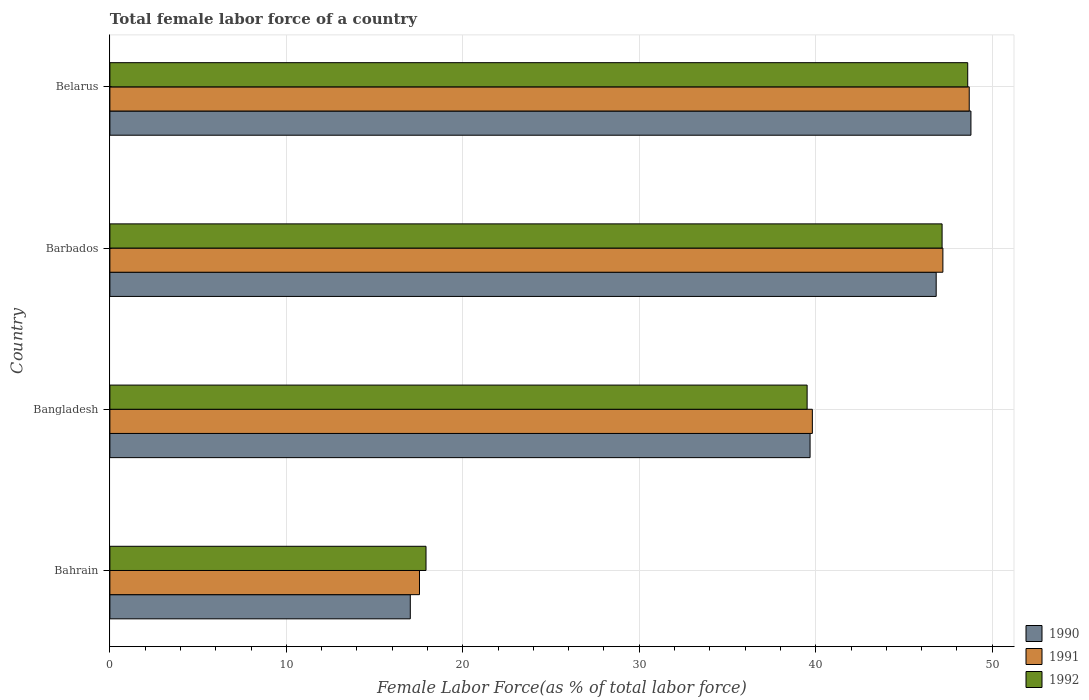How many groups of bars are there?
Your answer should be compact. 4. Are the number of bars on each tick of the Y-axis equal?
Ensure brevity in your answer.  Yes. What is the label of the 4th group of bars from the top?
Keep it short and to the point. Bahrain. What is the percentage of female labor force in 1992 in Bahrain?
Your answer should be very brief. 17.92. Across all countries, what is the maximum percentage of female labor force in 1991?
Provide a short and direct response. 48.7. Across all countries, what is the minimum percentage of female labor force in 1992?
Offer a terse response. 17.92. In which country was the percentage of female labor force in 1992 maximum?
Provide a succinct answer. Belarus. In which country was the percentage of female labor force in 1990 minimum?
Your response must be concise. Bahrain. What is the total percentage of female labor force in 1992 in the graph?
Offer a terse response. 153.21. What is the difference between the percentage of female labor force in 1991 in Bangladesh and that in Belarus?
Provide a short and direct response. -8.89. What is the difference between the percentage of female labor force in 1990 in Barbados and the percentage of female labor force in 1991 in Bahrain?
Keep it short and to the point. 29.28. What is the average percentage of female labor force in 1990 per country?
Offer a very short reply. 38.08. What is the difference between the percentage of female labor force in 1992 and percentage of female labor force in 1990 in Bangladesh?
Offer a very short reply. -0.17. What is the ratio of the percentage of female labor force in 1992 in Bahrain to that in Barbados?
Make the answer very short. 0.38. Is the percentage of female labor force in 1990 in Barbados less than that in Belarus?
Provide a succinct answer. Yes. What is the difference between the highest and the second highest percentage of female labor force in 1992?
Your response must be concise. 1.45. What is the difference between the highest and the lowest percentage of female labor force in 1992?
Provide a succinct answer. 30.7. In how many countries, is the percentage of female labor force in 1992 greater than the average percentage of female labor force in 1992 taken over all countries?
Keep it short and to the point. 3. Is the sum of the percentage of female labor force in 1990 in Barbados and Belarus greater than the maximum percentage of female labor force in 1991 across all countries?
Your response must be concise. Yes. What does the 1st bar from the bottom in Barbados represents?
Offer a very short reply. 1990. Is it the case that in every country, the sum of the percentage of female labor force in 1992 and percentage of female labor force in 1990 is greater than the percentage of female labor force in 1991?
Ensure brevity in your answer.  Yes. How many countries are there in the graph?
Provide a short and direct response. 4. What is the difference between two consecutive major ticks on the X-axis?
Your answer should be very brief. 10. Does the graph contain grids?
Your answer should be very brief. Yes. How many legend labels are there?
Provide a succinct answer. 3. What is the title of the graph?
Keep it short and to the point. Total female labor force of a country. Does "1996" appear as one of the legend labels in the graph?
Your answer should be very brief. No. What is the label or title of the X-axis?
Your answer should be compact. Female Labor Force(as % of total labor force). What is the label or title of the Y-axis?
Your answer should be compact. Country. What is the Female Labor Force(as % of total labor force) in 1990 in Bahrain?
Provide a short and direct response. 17.02. What is the Female Labor Force(as % of total labor force) of 1991 in Bahrain?
Your answer should be very brief. 17.55. What is the Female Labor Force(as % of total labor force) in 1992 in Bahrain?
Your answer should be compact. 17.92. What is the Female Labor Force(as % of total labor force) in 1990 in Bangladesh?
Provide a succinct answer. 39.68. What is the Female Labor Force(as % of total labor force) of 1991 in Bangladesh?
Your answer should be compact. 39.81. What is the Female Labor Force(as % of total labor force) of 1992 in Bangladesh?
Your answer should be very brief. 39.51. What is the Female Labor Force(as % of total labor force) in 1990 in Barbados?
Offer a terse response. 46.83. What is the Female Labor Force(as % of total labor force) of 1991 in Barbados?
Your answer should be compact. 47.21. What is the Female Labor Force(as % of total labor force) in 1992 in Barbados?
Offer a terse response. 47.16. What is the Female Labor Force(as % of total labor force) of 1990 in Belarus?
Offer a very short reply. 48.8. What is the Female Labor Force(as % of total labor force) in 1991 in Belarus?
Offer a very short reply. 48.7. What is the Female Labor Force(as % of total labor force) of 1992 in Belarus?
Your response must be concise. 48.61. Across all countries, what is the maximum Female Labor Force(as % of total labor force) in 1990?
Offer a terse response. 48.8. Across all countries, what is the maximum Female Labor Force(as % of total labor force) of 1991?
Your answer should be compact. 48.7. Across all countries, what is the maximum Female Labor Force(as % of total labor force) of 1992?
Ensure brevity in your answer.  48.61. Across all countries, what is the minimum Female Labor Force(as % of total labor force) of 1990?
Your response must be concise. 17.02. Across all countries, what is the minimum Female Labor Force(as % of total labor force) of 1991?
Offer a very short reply. 17.55. Across all countries, what is the minimum Female Labor Force(as % of total labor force) of 1992?
Your response must be concise. 17.92. What is the total Female Labor Force(as % of total labor force) of 1990 in the graph?
Offer a very short reply. 152.33. What is the total Female Labor Force(as % of total labor force) in 1991 in the graph?
Offer a very short reply. 153.26. What is the total Female Labor Force(as % of total labor force) in 1992 in the graph?
Give a very brief answer. 153.21. What is the difference between the Female Labor Force(as % of total labor force) of 1990 in Bahrain and that in Bangladesh?
Provide a succinct answer. -22.66. What is the difference between the Female Labor Force(as % of total labor force) in 1991 in Bahrain and that in Bangladesh?
Make the answer very short. -22.26. What is the difference between the Female Labor Force(as % of total labor force) of 1992 in Bahrain and that in Bangladesh?
Keep it short and to the point. -21.6. What is the difference between the Female Labor Force(as % of total labor force) in 1990 in Bahrain and that in Barbados?
Offer a very short reply. -29.8. What is the difference between the Female Labor Force(as % of total labor force) in 1991 in Bahrain and that in Barbados?
Your answer should be compact. -29.66. What is the difference between the Female Labor Force(as % of total labor force) in 1992 in Bahrain and that in Barbados?
Keep it short and to the point. -29.25. What is the difference between the Female Labor Force(as % of total labor force) of 1990 in Bahrain and that in Belarus?
Your response must be concise. -31.77. What is the difference between the Female Labor Force(as % of total labor force) of 1991 in Bahrain and that in Belarus?
Your response must be concise. -31.16. What is the difference between the Female Labor Force(as % of total labor force) of 1992 in Bahrain and that in Belarus?
Offer a terse response. -30.7. What is the difference between the Female Labor Force(as % of total labor force) in 1990 in Bangladesh and that in Barbados?
Keep it short and to the point. -7.15. What is the difference between the Female Labor Force(as % of total labor force) of 1991 in Bangladesh and that in Barbados?
Your answer should be compact. -7.4. What is the difference between the Female Labor Force(as % of total labor force) of 1992 in Bangladesh and that in Barbados?
Your answer should be very brief. -7.65. What is the difference between the Female Labor Force(as % of total labor force) of 1990 in Bangladesh and that in Belarus?
Ensure brevity in your answer.  -9.12. What is the difference between the Female Labor Force(as % of total labor force) of 1991 in Bangladesh and that in Belarus?
Provide a succinct answer. -8.89. What is the difference between the Female Labor Force(as % of total labor force) in 1992 in Bangladesh and that in Belarus?
Make the answer very short. -9.1. What is the difference between the Female Labor Force(as % of total labor force) of 1990 in Barbados and that in Belarus?
Your response must be concise. -1.97. What is the difference between the Female Labor Force(as % of total labor force) in 1991 in Barbados and that in Belarus?
Provide a succinct answer. -1.49. What is the difference between the Female Labor Force(as % of total labor force) in 1992 in Barbados and that in Belarus?
Your response must be concise. -1.45. What is the difference between the Female Labor Force(as % of total labor force) of 1990 in Bahrain and the Female Labor Force(as % of total labor force) of 1991 in Bangladesh?
Keep it short and to the point. -22.79. What is the difference between the Female Labor Force(as % of total labor force) of 1990 in Bahrain and the Female Labor Force(as % of total labor force) of 1992 in Bangladesh?
Offer a terse response. -22.49. What is the difference between the Female Labor Force(as % of total labor force) in 1991 in Bahrain and the Female Labor Force(as % of total labor force) in 1992 in Bangladesh?
Offer a terse response. -21.97. What is the difference between the Female Labor Force(as % of total labor force) in 1990 in Bahrain and the Female Labor Force(as % of total labor force) in 1991 in Barbados?
Provide a succinct answer. -30.18. What is the difference between the Female Labor Force(as % of total labor force) of 1990 in Bahrain and the Female Labor Force(as % of total labor force) of 1992 in Barbados?
Your response must be concise. -30.14. What is the difference between the Female Labor Force(as % of total labor force) in 1991 in Bahrain and the Female Labor Force(as % of total labor force) in 1992 in Barbados?
Make the answer very short. -29.62. What is the difference between the Female Labor Force(as % of total labor force) in 1990 in Bahrain and the Female Labor Force(as % of total labor force) in 1991 in Belarus?
Provide a succinct answer. -31.68. What is the difference between the Female Labor Force(as % of total labor force) of 1990 in Bahrain and the Female Labor Force(as % of total labor force) of 1992 in Belarus?
Offer a very short reply. -31.59. What is the difference between the Female Labor Force(as % of total labor force) of 1991 in Bahrain and the Female Labor Force(as % of total labor force) of 1992 in Belarus?
Provide a short and direct response. -31.07. What is the difference between the Female Labor Force(as % of total labor force) in 1990 in Bangladesh and the Female Labor Force(as % of total labor force) in 1991 in Barbados?
Keep it short and to the point. -7.53. What is the difference between the Female Labor Force(as % of total labor force) of 1990 in Bangladesh and the Female Labor Force(as % of total labor force) of 1992 in Barbados?
Ensure brevity in your answer.  -7.48. What is the difference between the Female Labor Force(as % of total labor force) in 1991 in Bangladesh and the Female Labor Force(as % of total labor force) in 1992 in Barbados?
Make the answer very short. -7.35. What is the difference between the Female Labor Force(as % of total labor force) of 1990 in Bangladesh and the Female Labor Force(as % of total labor force) of 1991 in Belarus?
Your answer should be compact. -9.02. What is the difference between the Female Labor Force(as % of total labor force) in 1990 in Bangladesh and the Female Labor Force(as % of total labor force) in 1992 in Belarus?
Keep it short and to the point. -8.93. What is the difference between the Female Labor Force(as % of total labor force) of 1991 in Bangladesh and the Female Labor Force(as % of total labor force) of 1992 in Belarus?
Provide a short and direct response. -8.8. What is the difference between the Female Labor Force(as % of total labor force) of 1990 in Barbados and the Female Labor Force(as % of total labor force) of 1991 in Belarus?
Make the answer very short. -1.87. What is the difference between the Female Labor Force(as % of total labor force) of 1990 in Barbados and the Female Labor Force(as % of total labor force) of 1992 in Belarus?
Offer a terse response. -1.79. What is the difference between the Female Labor Force(as % of total labor force) in 1991 in Barbados and the Female Labor Force(as % of total labor force) in 1992 in Belarus?
Ensure brevity in your answer.  -1.41. What is the average Female Labor Force(as % of total labor force) in 1990 per country?
Ensure brevity in your answer.  38.08. What is the average Female Labor Force(as % of total labor force) in 1991 per country?
Make the answer very short. 38.32. What is the average Female Labor Force(as % of total labor force) of 1992 per country?
Your answer should be compact. 38.3. What is the difference between the Female Labor Force(as % of total labor force) of 1990 and Female Labor Force(as % of total labor force) of 1991 in Bahrain?
Make the answer very short. -0.52. What is the difference between the Female Labor Force(as % of total labor force) in 1990 and Female Labor Force(as % of total labor force) in 1992 in Bahrain?
Provide a short and direct response. -0.89. What is the difference between the Female Labor Force(as % of total labor force) of 1991 and Female Labor Force(as % of total labor force) of 1992 in Bahrain?
Give a very brief answer. -0.37. What is the difference between the Female Labor Force(as % of total labor force) in 1990 and Female Labor Force(as % of total labor force) in 1991 in Bangladesh?
Make the answer very short. -0.13. What is the difference between the Female Labor Force(as % of total labor force) in 1990 and Female Labor Force(as % of total labor force) in 1992 in Bangladesh?
Give a very brief answer. 0.17. What is the difference between the Female Labor Force(as % of total labor force) in 1991 and Female Labor Force(as % of total labor force) in 1992 in Bangladesh?
Your answer should be compact. 0.3. What is the difference between the Female Labor Force(as % of total labor force) in 1990 and Female Labor Force(as % of total labor force) in 1991 in Barbados?
Keep it short and to the point. -0.38. What is the difference between the Female Labor Force(as % of total labor force) in 1990 and Female Labor Force(as % of total labor force) in 1992 in Barbados?
Keep it short and to the point. -0.33. What is the difference between the Female Labor Force(as % of total labor force) of 1991 and Female Labor Force(as % of total labor force) of 1992 in Barbados?
Offer a terse response. 0.05. What is the difference between the Female Labor Force(as % of total labor force) in 1990 and Female Labor Force(as % of total labor force) in 1991 in Belarus?
Ensure brevity in your answer.  0.1. What is the difference between the Female Labor Force(as % of total labor force) of 1990 and Female Labor Force(as % of total labor force) of 1992 in Belarus?
Keep it short and to the point. 0.18. What is the difference between the Female Labor Force(as % of total labor force) in 1991 and Female Labor Force(as % of total labor force) in 1992 in Belarus?
Your answer should be very brief. 0.09. What is the ratio of the Female Labor Force(as % of total labor force) in 1990 in Bahrain to that in Bangladesh?
Give a very brief answer. 0.43. What is the ratio of the Female Labor Force(as % of total labor force) in 1991 in Bahrain to that in Bangladesh?
Your response must be concise. 0.44. What is the ratio of the Female Labor Force(as % of total labor force) in 1992 in Bahrain to that in Bangladesh?
Give a very brief answer. 0.45. What is the ratio of the Female Labor Force(as % of total labor force) in 1990 in Bahrain to that in Barbados?
Offer a terse response. 0.36. What is the ratio of the Female Labor Force(as % of total labor force) in 1991 in Bahrain to that in Barbados?
Give a very brief answer. 0.37. What is the ratio of the Female Labor Force(as % of total labor force) of 1992 in Bahrain to that in Barbados?
Your answer should be very brief. 0.38. What is the ratio of the Female Labor Force(as % of total labor force) in 1990 in Bahrain to that in Belarus?
Provide a short and direct response. 0.35. What is the ratio of the Female Labor Force(as % of total labor force) in 1991 in Bahrain to that in Belarus?
Your answer should be compact. 0.36. What is the ratio of the Female Labor Force(as % of total labor force) in 1992 in Bahrain to that in Belarus?
Offer a terse response. 0.37. What is the ratio of the Female Labor Force(as % of total labor force) in 1990 in Bangladesh to that in Barbados?
Ensure brevity in your answer.  0.85. What is the ratio of the Female Labor Force(as % of total labor force) of 1991 in Bangladesh to that in Barbados?
Ensure brevity in your answer.  0.84. What is the ratio of the Female Labor Force(as % of total labor force) in 1992 in Bangladesh to that in Barbados?
Keep it short and to the point. 0.84. What is the ratio of the Female Labor Force(as % of total labor force) in 1990 in Bangladesh to that in Belarus?
Ensure brevity in your answer.  0.81. What is the ratio of the Female Labor Force(as % of total labor force) of 1991 in Bangladesh to that in Belarus?
Provide a succinct answer. 0.82. What is the ratio of the Female Labor Force(as % of total labor force) in 1992 in Bangladesh to that in Belarus?
Give a very brief answer. 0.81. What is the ratio of the Female Labor Force(as % of total labor force) of 1990 in Barbados to that in Belarus?
Provide a short and direct response. 0.96. What is the ratio of the Female Labor Force(as % of total labor force) in 1991 in Barbados to that in Belarus?
Provide a short and direct response. 0.97. What is the ratio of the Female Labor Force(as % of total labor force) in 1992 in Barbados to that in Belarus?
Your answer should be compact. 0.97. What is the difference between the highest and the second highest Female Labor Force(as % of total labor force) of 1990?
Give a very brief answer. 1.97. What is the difference between the highest and the second highest Female Labor Force(as % of total labor force) in 1991?
Your answer should be very brief. 1.49. What is the difference between the highest and the second highest Female Labor Force(as % of total labor force) in 1992?
Make the answer very short. 1.45. What is the difference between the highest and the lowest Female Labor Force(as % of total labor force) of 1990?
Offer a terse response. 31.77. What is the difference between the highest and the lowest Female Labor Force(as % of total labor force) in 1991?
Your response must be concise. 31.16. What is the difference between the highest and the lowest Female Labor Force(as % of total labor force) in 1992?
Your answer should be very brief. 30.7. 